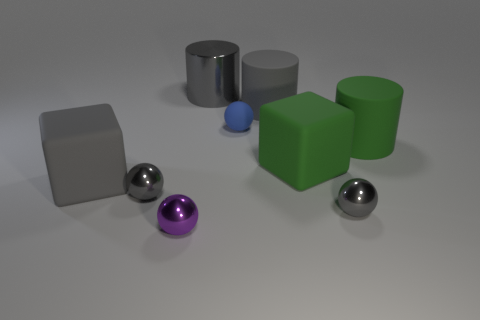How many large things are either red matte blocks or gray cubes?
Your answer should be compact. 1. The green cylinder has what size?
Provide a short and direct response. Large. Is the size of the blue matte sphere the same as the block left of the purple shiny sphere?
Ensure brevity in your answer.  No. How many brown objects are big cubes or small objects?
Offer a very short reply. 0. How many tiny purple things are there?
Ensure brevity in your answer.  1. There is a cylinder right of the large gray rubber cylinder; what size is it?
Offer a very short reply. Large. Is the gray matte block the same size as the purple shiny thing?
Your response must be concise. No. How many things are tiny blue things or gray objects left of the large gray metal object?
Ensure brevity in your answer.  3. What is the tiny blue ball made of?
Your answer should be compact. Rubber. Is there any other thing of the same color as the metallic cylinder?
Ensure brevity in your answer.  Yes. 